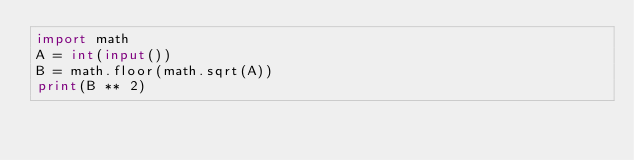<code> <loc_0><loc_0><loc_500><loc_500><_Python_>import math
A = int(input())
B = math.floor(math.sqrt(A))
print(B ** 2)</code> 